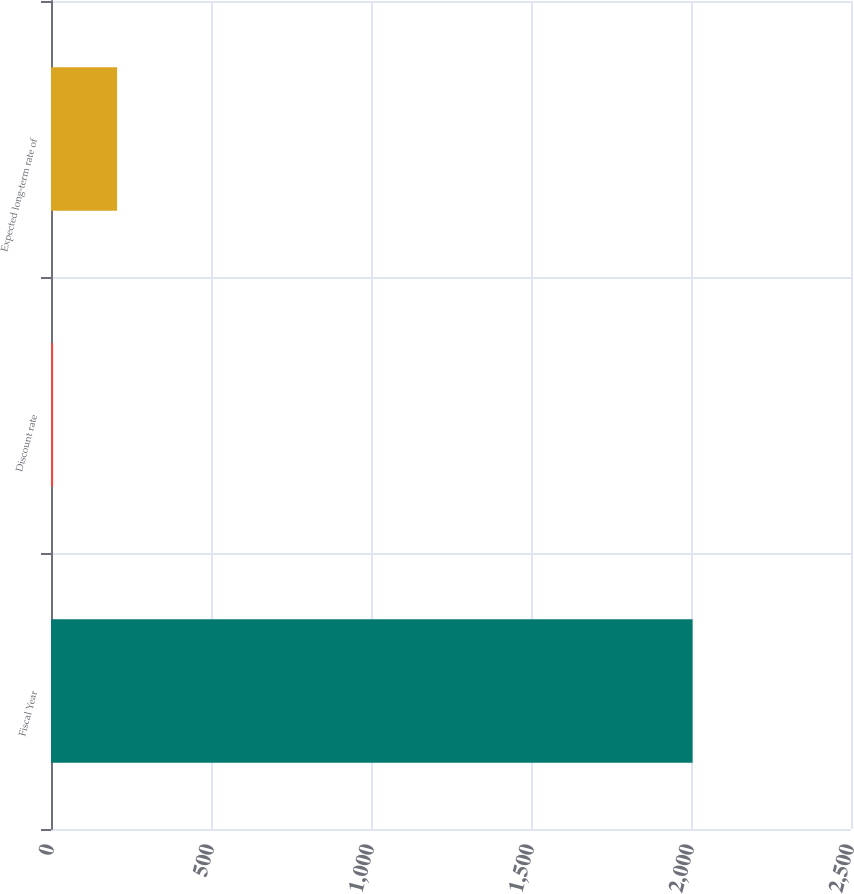Convert chart to OTSL. <chart><loc_0><loc_0><loc_500><loc_500><bar_chart><fcel>Fiscal Year<fcel>Discount rate<fcel>Expected long-term rate of<nl><fcel>2005<fcel>6.65<fcel>206.49<nl></chart> 